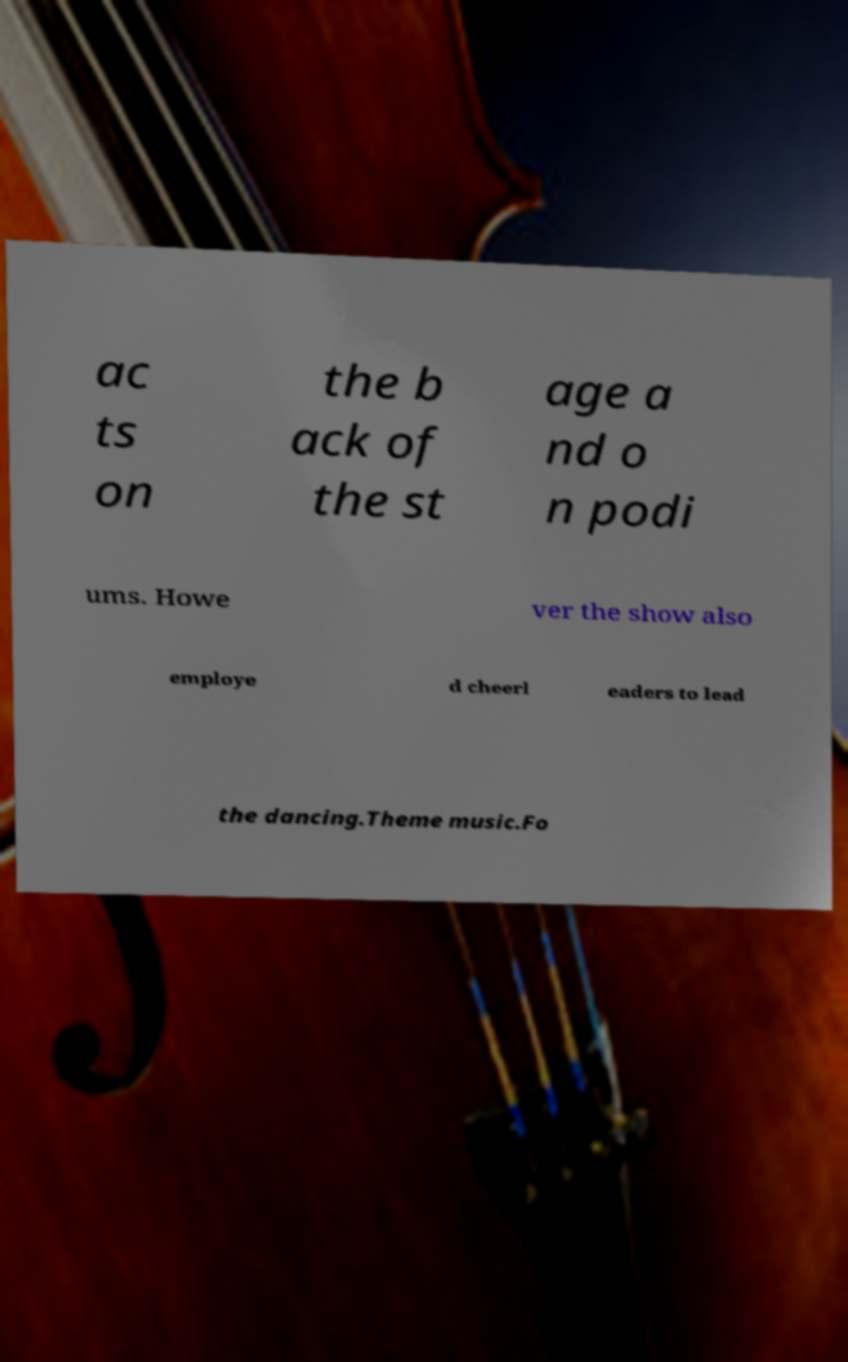Please read and relay the text visible in this image. What does it say? ac ts on the b ack of the st age a nd o n podi ums. Howe ver the show also employe d cheerl eaders to lead the dancing.Theme music.Fo 